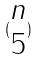<formula> <loc_0><loc_0><loc_500><loc_500>( \begin{matrix} n \\ 5 \end{matrix} )</formula> 